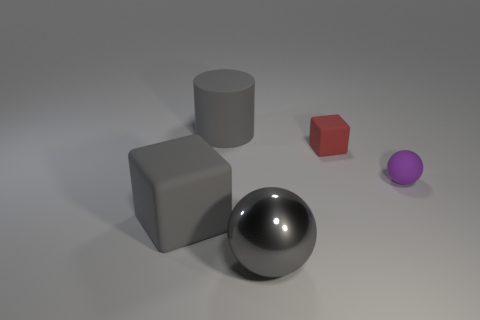Add 4 large purple shiny objects. How many objects exist? 9 Subtract all cylinders. How many objects are left? 4 Subtract all cyan metal cubes. Subtract all tiny purple rubber things. How many objects are left? 4 Add 2 large matte cubes. How many large matte cubes are left? 3 Add 1 red rubber blocks. How many red rubber blocks exist? 2 Subtract 0 purple cylinders. How many objects are left? 5 